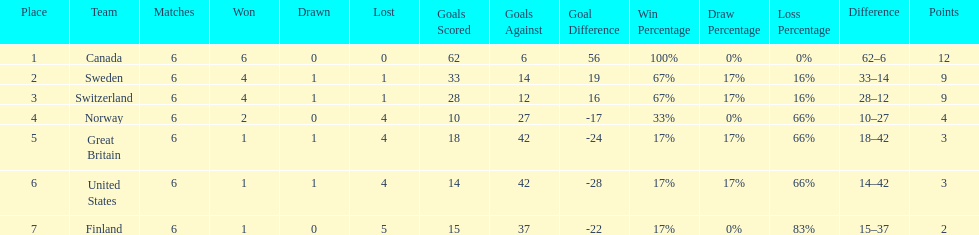What team placed after canada? Sweden. 